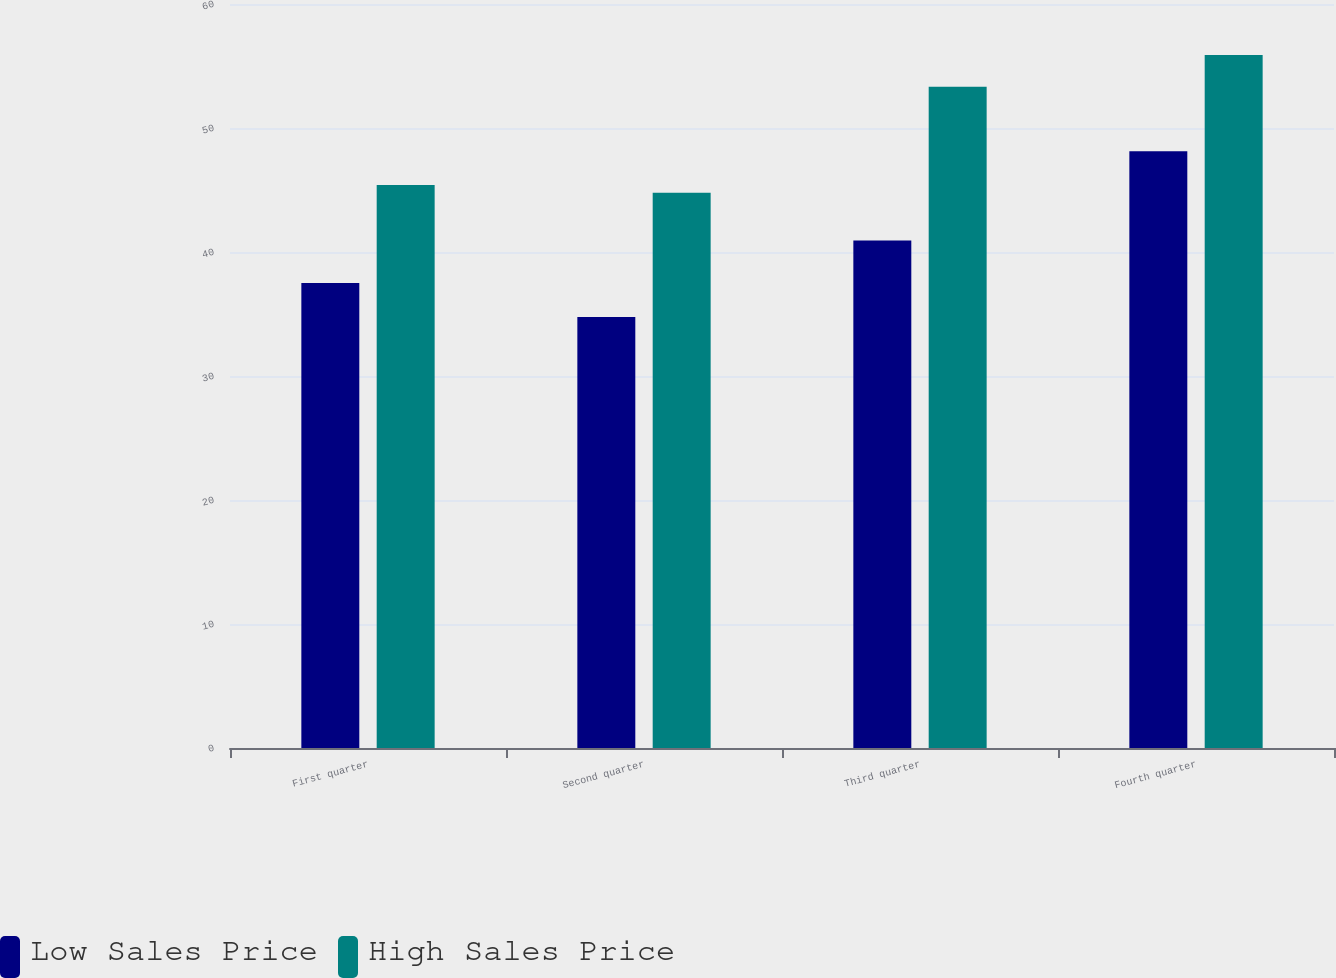<chart> <loc_0><loc_0><loc_500><loc_500><stacked_bar_chart><ecel><fcel>First quarter<fcel>Second quarter<fcel>Third quarter<fcel>Fourth quarter<nl><fcel>Low Sales Price<fcel>37.51<fcel>34.76<fcel>40.93<fcel>48.13<nl><fcel>High Sales Price<fcel>45.41<fcel>44.77<fcel>53.33<fcel>55.89<nl></chart> 